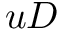Convert formula to latex. <formula><loc_0><loc_0><loc_500><loc_500>u D</formula> 